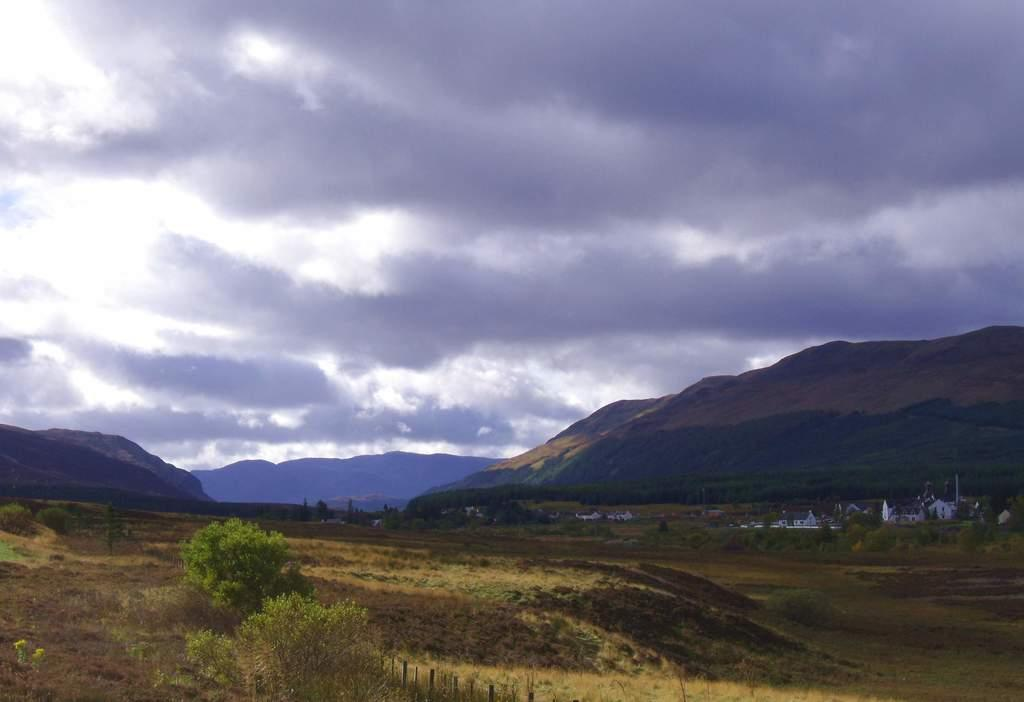What type of vegetation can be seen in the image? There are trees and plants in the image. What type of structures are visible in the image? There are houses in the image. What other objects can be seen in the image? There are poles and mountains in the image. What is visible in the background of the image? The sky is visible in the background of the image. What can be observed in the sky? Clouds are present in the sky. What size is the kitty that is playing with the plants in the image? There is no kitty present in the image, and therefore no such activity can be observed. How many plants are in the image? The image contains trees and plants, but the exact number cannot be determined without more specific information. 